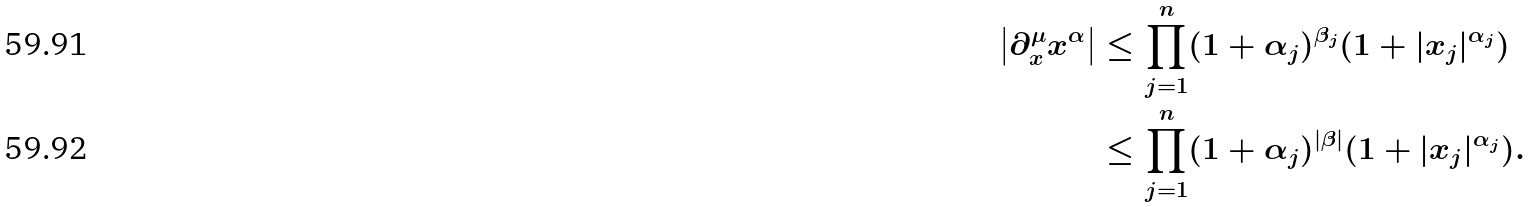<formula> <loc_0><loc_0><loc_500><loc_500>\left | \partial _ { x } ^ { \mu } x ^ { \alpha } \right | & \leq \prod _ { j = 1 } ^ { n } ( 1 + \alpha _ { j } ) ^ { \beta _ { j } } ( 1 + | x _ { j } | ^ { \alpha _ { j } } ) \\ & \leq \prod _ { j = 1 } ^ { n } ( 1 + \alpha _ { j } ) ^ { | \beta | } ( 1 + | x _ { j } | ^ { \alpha _ { j } } ) .</formula> 